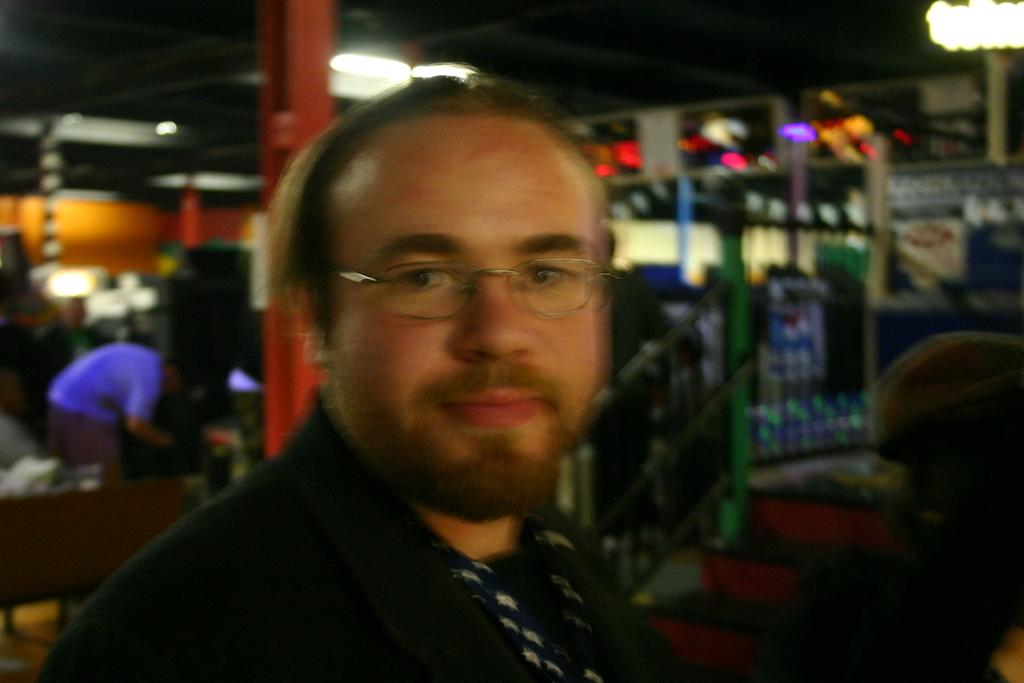What is the person in the image wearing on their face? The person in the image is wearing spectacles. What architectural feature can be seen in the image? There are pillars in the image. What type of illumination is present in the image? There are lights in the image. Can you describe any other objects in the image? There are other unspecified objects in the image. What is the grip of the acoustics in the image? There is no mention of acoustics or grip in the image, so this question cannot be answered. 